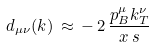Convert formula to latex. <formula><loc_0><loc_0><loc_500><loc_500>d _ { \mu \nu } ( k ) \, \approx \, - \, 2 \, \frac { p ^ { \mu } _ { B } k ^ { \nu } _ { T } } { x \, s }</formula> 